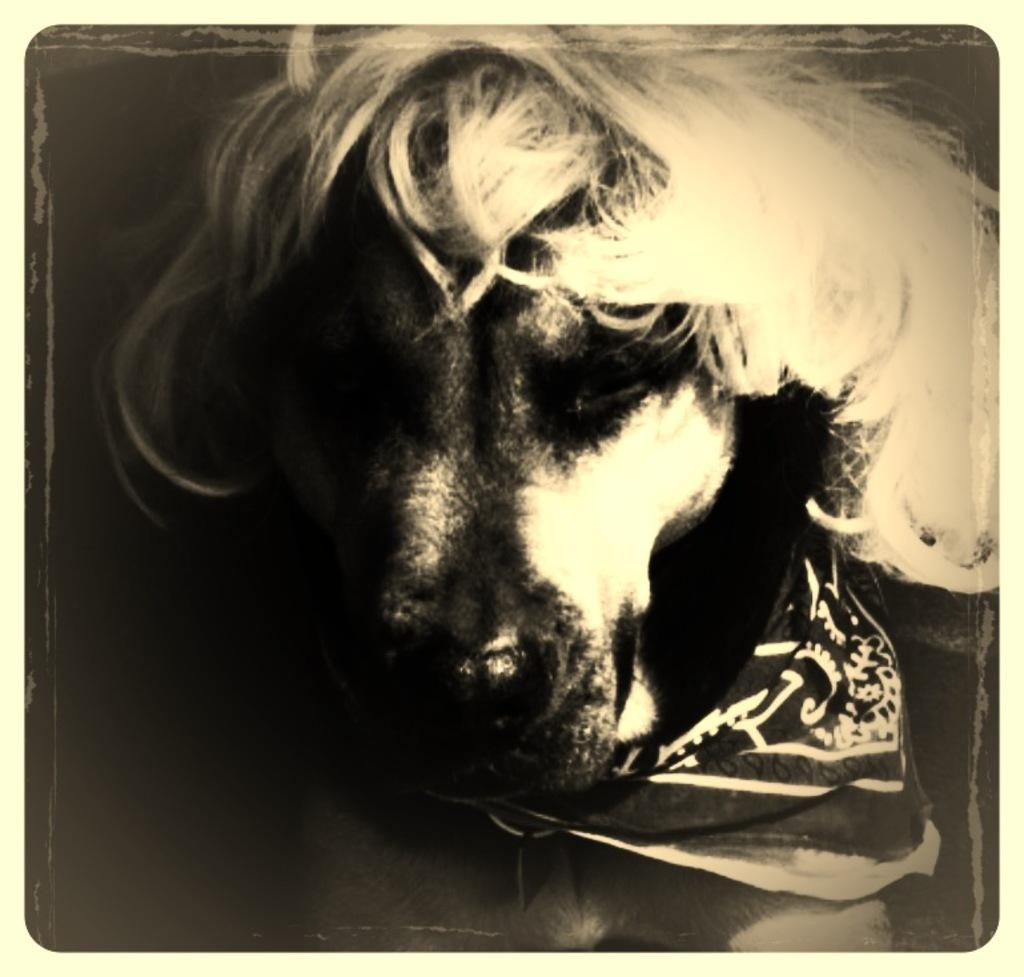What type of animal is in the picture? There is a dog in the picture. What is on the dog's neck? The dog has a cloth on its neck. What can be observed on the left side of the image? There is darkness on the left side of the image. What type of footwear is the dog wearing in the image? There is no footwear visible on the dog in the image. What is the dog's interest in the image? The image does not provide information about the dog's interests. 